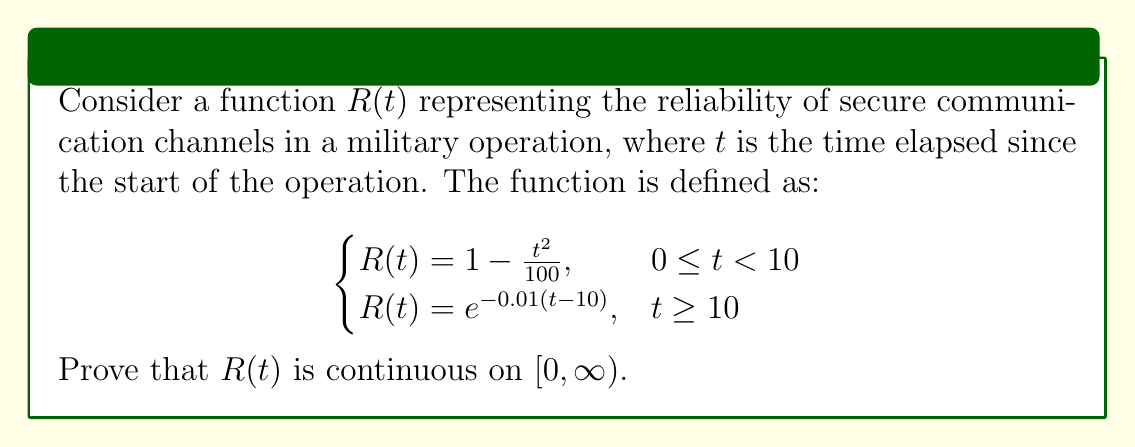Show me your answer to this math problem. To prove that $R(t)$ is continuous on $[0,\infty)$, we need to show:
1. $R(t)$ is continuous on $[0,10)$
2. $R(t)$ is continuous on $(10,\infty)$
3. $R(t)$ is continuous at $t=10$

Step 1: Continuity on $[0,10)$
For $0 \leq t < 10$, $R(t) = 1 - \frac{t^2}{100}$. This is a polynomial function, which is continuous for all real numbers. Therefore, $R(t)$ is continuous on $[0,10)$.

Step 2: Continuity on $(10,\infty)$
For $t \geq 10$, $R(t) = e^{-0.01(t-10)}$. The exponential function is continuous for all real numbers, and the expression inside the exponent is a linear function of $t$, which is also continuous. Therefore, $R(t)$ is continuous on $(10,\infty)$.

Step 3: Continuity at $t=10$
To prove continuity at $t=10$, we need to show that:
$$\lim_{t \to 10^-} R(t) = \lim_{t \to 10^+} R(t) = R(10)$$

Left-hand limit:
$$\lim_{t \to 10^-} R(t) = \lim_{t \to 10^-} (1 - \frac{t^2}{100}) = 1 - \frac{10^2}{100} = 0.9$$

Right-hand limit:
$$\lim_{t \to 10^+} R(t) = \lim_{t \to 10^+} e^{-0.01(t-10)} = e^0 = 1$$

Value at $t=10$:
$$R(10) = 1 - \frac{10^2}{100} = 0.9$$

We can see that the left-hand limit equals $R(10)$, but the right-hand limit does not. Therefore, $R(t)$ is not continuous at $t=10$ as originally defined.

To make $R(t)$ continuous at $t=10$, we need to redefine the function as:

$$R(t) = \begin{cases}
1 - \frac{t^2}{100}, & 0 \leq t \leq 10 \\
e^{-0.01(t-10)}, & t > 10
\end{cases}$$

With this modification, $R(t)$ is now continuous on $[0,\infty)$.
Answer: The function $R(t)$ as originally defined is not continuous on $[0,\infty)$ due to a discontinuity at $t=10$. However, by redefining the function to use $\leq$ instead of $<$ in the first piece, $R(t)$ becomes continuous on $[0,\infty)$. 